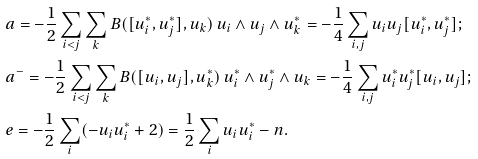<formula> <loc_0><loc_0><loc_500><loc_500>& a = - \frac { 1 } { 2 } \sum _ { i < j } \sum _ { k } B ( [ u ^ { * } _ { i } , u ^ { * } _ { j } ] , u _ { k } ) \, u _ { i } \wedge u _ { j } \wedge u ^ { * } _ { k } = - \frac { 1 } { 4 } \sum _ { i , j } u _ { i } u _ { j } [ u ^ { * } _ { i } , u ^ { * } _ { j } ] ; \\ & a ^ { - } = - \frac { 1 } { 2 } \sum _ { i < j } \sum _ { k } B ( [ u _ { i } , u _ { j } ] , u ^ { * } _ { k } ) \, u ^ { * } _ { i } \wedge u ^ { * } _ { j } \wedge u _ { k } = - \frac { 1 } { 4 } \sum _ { i , j } u ^ { * } _ { i } u ^ { * } _ { j } [ u _ { i } , u _ { j } ] ; \\ & e = - \frac { 1 } { 2 } \sum _ { i } ( - u _ { i } u ^ { * } _ { i } + 2 ) = \frac { 1 } { 2 } \sum _ { i } u _ { i } u ^ { * } _ { i } - n .</formula> 